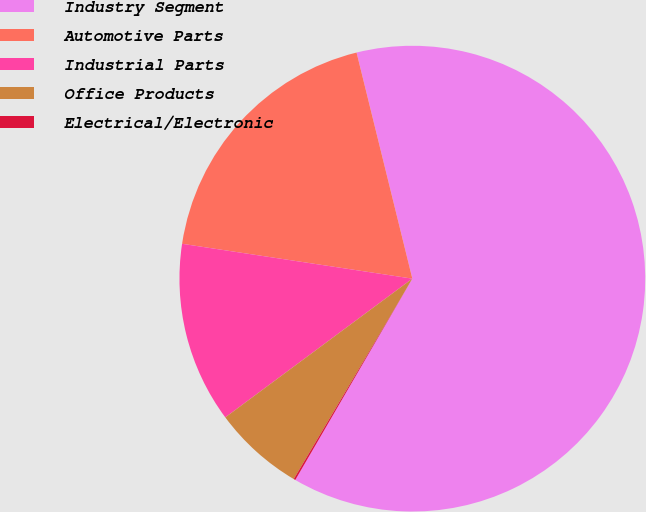<chart> <loc_0><loc_0><loc_500><loc_500><pie_chart><fcel>Industry Segment<fcel>Automotive Parts<fcel>Industrial Parts<fcel>Office Products<fcel>Electrical/Electronic<nl><fcel>62.24%<fcel>18.76%<fcel>12.55%<fcel>6.34%<fcel>0.12%<nl></chart> 